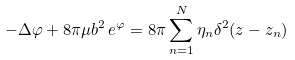<formula> <loc_0><loc_0><loc_500><loc_500>- \Delta \varphi + 8 \pi \mu b ^ { 2 } \, e ^ { \varphi } = 8 \pi \sum _ { n = 1 } ^ { N } \eta _ { n } \delta ^ { 2 } ( z - z _ { n } )</formula> 